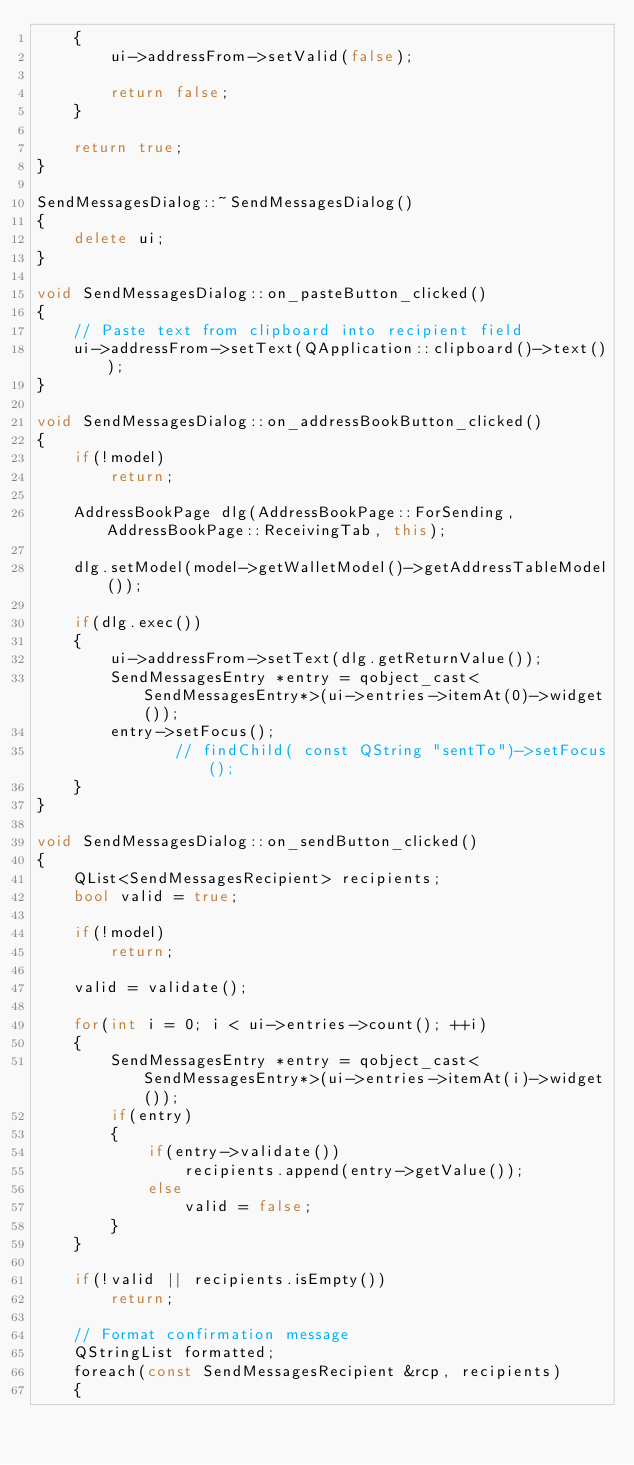Convert code to text. <code><loc_0><loc_0><loc_500><loc_500><_C++_>    {
        ui->addressFrom->setValid(false);

        return false;
    }

    return true;
}

SendMessagesDialog::~SendMessagesDialog()
{
    delete ui;
}

void SendMessagesDialog::on_pasteButton_clicked()
{
    // Paste text from clipboard into recipient field
    ui->addressFrom->setText(QApplication::clipboard()->text());
}

void SendMessagesDialog::on_addressBookButton_clicked()
{
    if(!model)
        return;

    AddressBookPage dlg(AddressBookPage::ForSending, AddressBookPage::ReceivingTab, this);

    dlg.setModel(model->getWalletModel()->getAddressTableModel());

    if(dlg.exec())
    {
        ui->addressFrom->setText(dlg.getReturnValue());
        SendMessagesEntry *entry = qobject_cast<SendMessagesEntry*>(ui->entries->itemAt(0)->widget());
        entry->setFocus();
               // findChild( const QString "sentTo")->setFocus();
    }
}

void SendMessagesDialog::on_sendButton_clicked()
{
    QList<SendMessagesRecipient> recipients;
    bool valid = true;

    if(!model)
        return;

    valid = validate();

    for(int i = 0; i < ui->entries->count(); ++i)
    {
        SendMessagesEntry *entry = qobject_cast<SendMessagesEntry*>(ui->entries->itemAt(i)->widget());
        if(entry)
        {
            if(entry->validate())
                recipients.append(entry->getValue());
            else
                valid = false;
        }
    }

    if(!valid || recipients.isEmpty())
        return;

    // Format confirmation message
    QStringList formatted;
    foreach(const SendMessagesRecipient &rcp, recipients)
    {</code> 